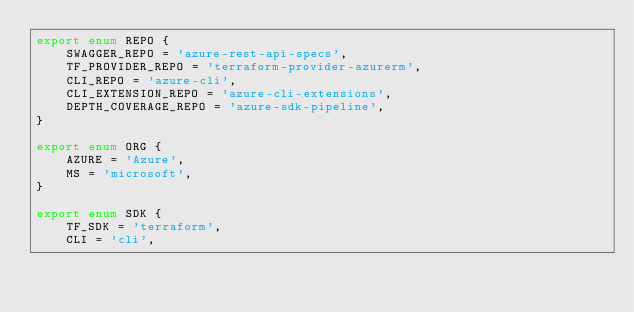Convert code to text. <code><loc_0><loc_0><loc_500><loc_500><_TypeScript_>export enum REPO {
    SWAGGER_REPO = 'azure-rest-api-specs',
    TF_PROVIDER_REPO = 'terraform-provider-azurerm',
    CLI_REPO = 'azure-cli',
    CLI_EXTENSION_REPO = 'azure-cli-extensions',
    DEPTH_COVERAGE_REPO = 'azure-sdk-pipeline',
}

export enum ORG {
    AZURE = 'Azure',
    MS = 'microsoft',
}

export enum SDK {
    TF_SDK = 'terraform',
    CLI = 'cli',</code> 